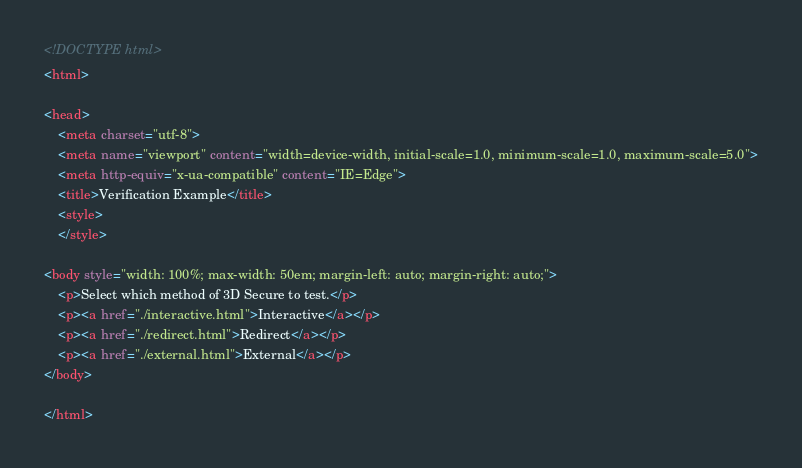<code> <loc_0><loc_0><loc_500><loc_500><_HTML_><!DOCTYPE html>
<html>

<head>
	<meta charset="utf-8">
	<meta name="viewport" content="width=device-width, initial-scale=1.0, minimum-scale=1.0, maximum-scale=5.0">
	<meta http-equiv="x-ua-compatible" content="IE=Edge">
	<title>Verification Example</title>
	<style>
	</style>

<body style="width: 100%; max-width: 50em; margin-left: auto; margin-right: auto;">
	<p>Select which method of 3D Secure to test.</p>
	<p><a href="./interactive.html">Interactive</a></p>
	<p><a href="./redirect.html">Redirect</a></p>
	<p><a href="./external.html">External</a></p>
</body>

</html></code> 